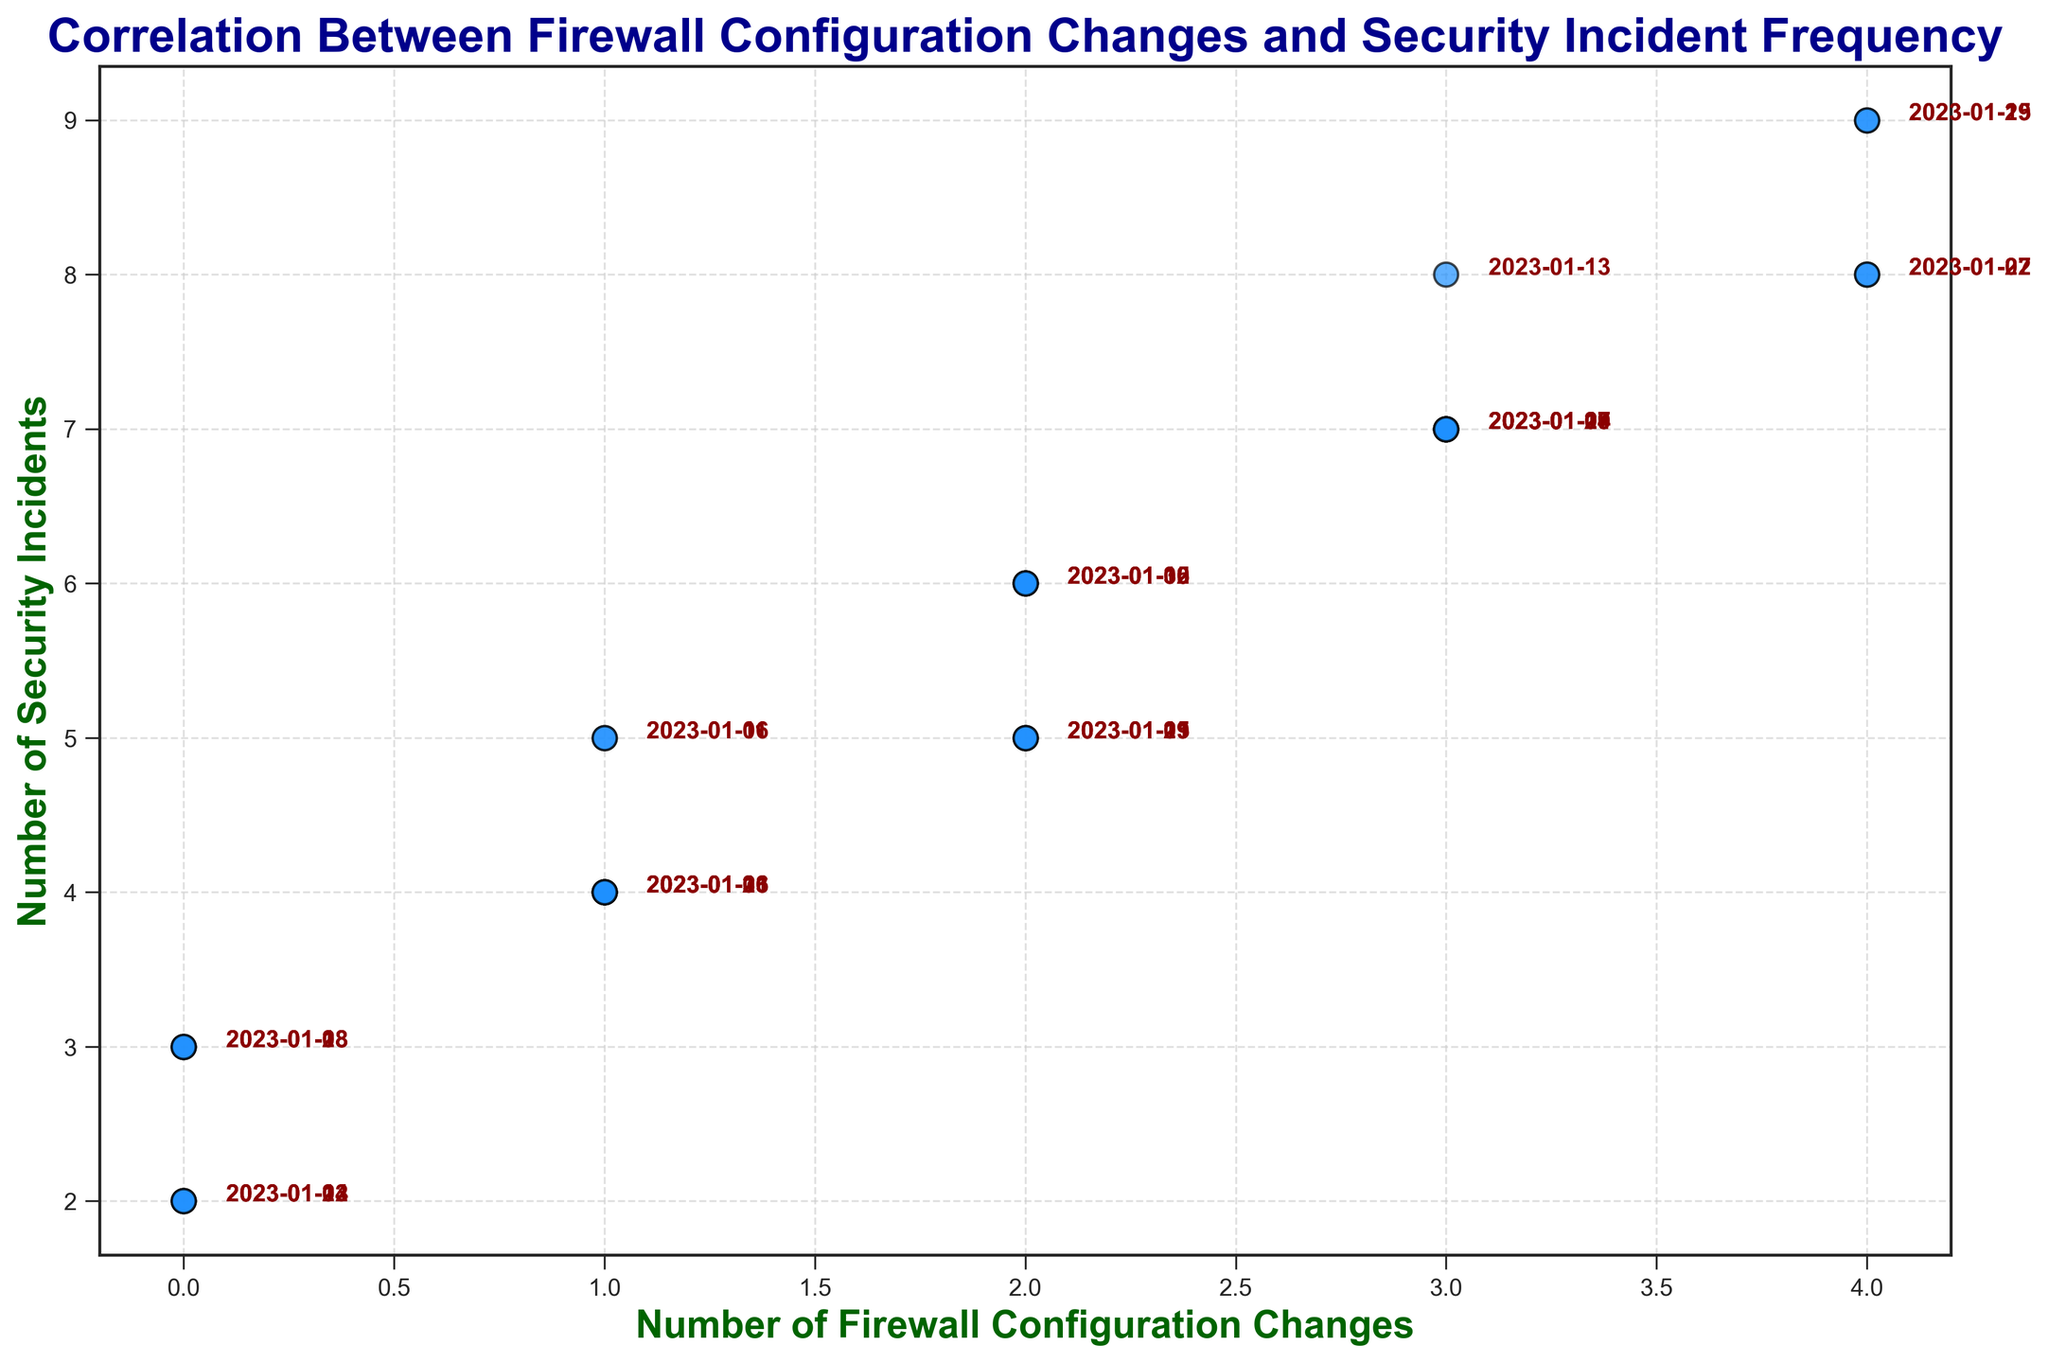What is the trend in the number of security incidents relative to firewall configuration changes? By examining the scatter plot, we observe that as the number of firewall configuration changes increases, the number of security incidents tends to increase as well.
Answer: Increasing Which date had the highest number of security incidents? By looking at the scatter plot and the annotated dates, it is clear that the date with the highest number of security incidents (9 incidents) is 2023-01-15 and 2023-01-29.
Answer: 2023-01-15 and 2023-01-29 On average, how many security incidents occur when there are 2 firewall changes? The points corresponding to 2 firewall changes have security incidents: 5, 6, 6, 5, 6, and 5. The average is (5+6+6+5+6+5) / 6 = 33 / 6 = 5.5 incidents.
Answer: 5.5 Which date had the lowest number of firewall changes and how many security incidents occurred on that day? From the scatter plot, we see the lowest number of firewall changes is 0, and the corresponding dates are 2023-01-02, 2023-01-08, 2023-01-14, 2023-01-18, and 2023-01-23, each having 2 or 3 security incidents.
Answer: 2023-01-02, 2023-01-08, 2023-01-14, 2023-01-18, and 2023-01-23; 2 or 3 security incidents What is the range of security incidents when there are 3 firewall configuration changes? The scatter plot shows the points for 3 firewall changes have security incidents as follows: 7, 7, 7, 7, and 8. Therefore, the range is the difference between the maximum and minimum values: 8 - 7 = 1 incident.
Answer: 1 Compare the number of security incidents for 1 firewall change and 4 firewall changes. Observing the scatter plot, for 1 firewall change, the security incidents are 4, 5, 5, 4, 4, 4. For 4 firewall changes, the security incidents are 8, 9, 8, 9, 9. Thus, 4 firewall changes yield higher incidents than 1 firewall change.
Answer: 4 changes > 1 change How does the frequency of firewall changes correlate with the number of security incidents? By looking at the general pattern in the scatter plot, it can be observed that higher frequencies of firewall changes (like 3 or 4 changes) tend to correspond with a higher number of security incidents, indicating a potential positive correlation.
Answer: Positive correlation What is the sum of security incidents on days with no firewall changes? On days with no firewall changes (0), the security incidents are 2, 3, 2, 3, 2, 3. Summing these values gives 2 + 3 + 2 + 3 + 2 + 3 = 15.
Answer: 15 What visual attributes help convey the information in the scatter plot more effectively? The scatter plot uses color (dodgerblue) to mark each point, and all points are annotated with dates in darkred, which aids in identifying specific data points. The grid lines and labels also help in visual clarity.
Answer: Color and annotations What is the median number of security incidents across all dates in the dataset? To find the median, we list all the security incidents in ascending order: 2, 2, 2, 2, 2, 3, 3, 3, 3, 4, 4, 4, 4, 4, 5, 5, 5, 5, 5, 6, 6, 6, 6, 7, 7, 7, 7, 7, 8, 8, 9, 9. The median is the middle value (or the average of the two middle values in case of an even number of data points). Thus, the median is 5.
Answer: 5 